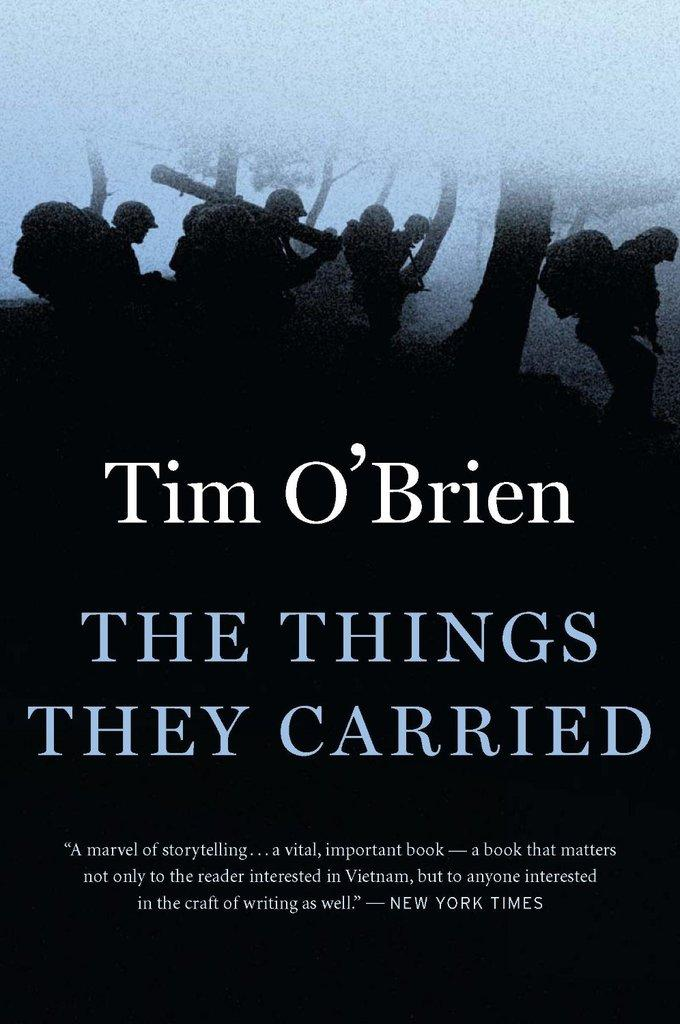<image>
Summarize the visual content of the image. Tim O' Brien presents The Things They Carried book of storytelling. 